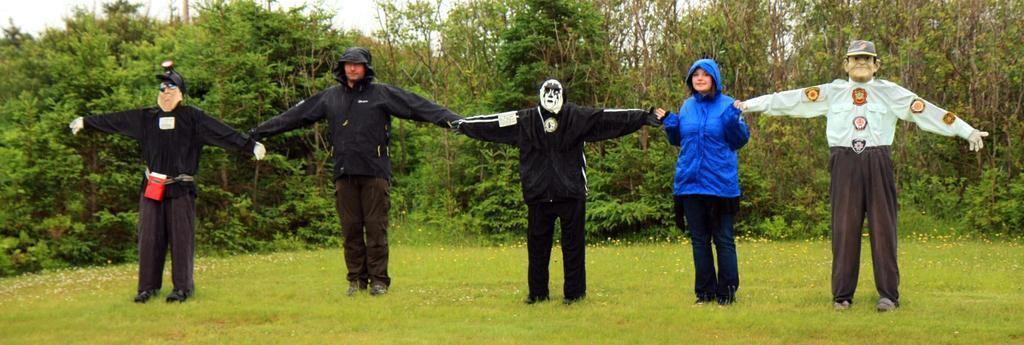Who or what can be seen in the image? There are persons in the image. What objects are on the ground in the image? There are scarecrows on the ground in the image. What type of natural environment is visible in the background of the image? There are trees in the background of the image. What is visible in the sky in the image? The sky is visible in the background of the image. What type of bells can be heard ringing in the image? There are no bells present in the image, and therefore no sound can be heard. Can you spot the payment method used by the persons in the image? There is no mention of payment or any payment method in the image. 